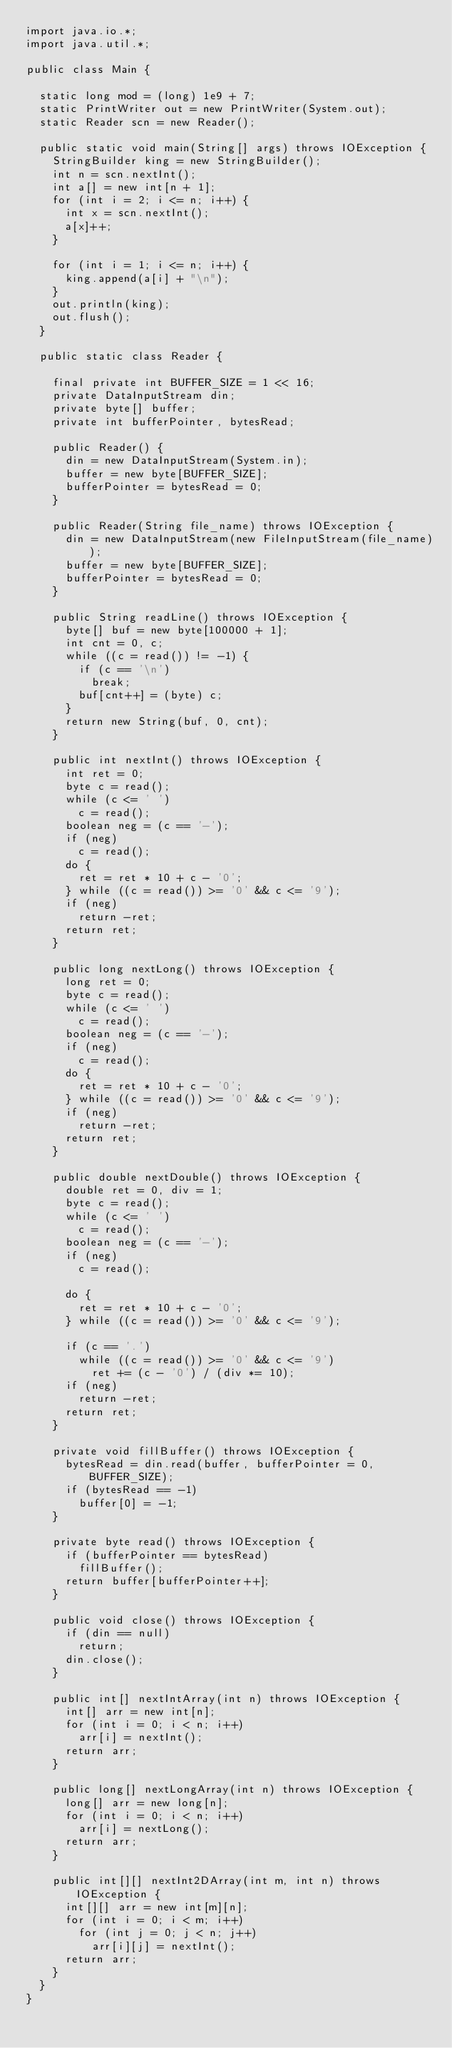<code> <loc_0><loc_0><loc_500><loc_500><_Java_>import java.io.*;
import java.util.*;

public class Main {

	static long mod = (long) 1e9 + 7;
	static PrintWriter out = new PrintWriter(System.out);
	static Reader scn = new Reader();

	public static void main(String[] args) throws IOException {
		StringBuilder king = new StringBuilder();
		int n = scn.nextInt();
		int a[] = new int[n + 1];
		for (int i = 2; i <= n; i++) {
			int x = scn.nextInt();
			a[x]++;
		}

		for (int i = 1; i <= n; i++) {
			king.append(a[i] + "\n");
		}
		out.println(king);
		out.flush();
	}

	public static class Reader {

		final private int BUFFER_SIZE = 1 << 16;
		private DataInputStream din;
		private byte[] buffer;
		private int bufferPointer, bytesRead;

		public Reader() {
			din = new DataInputStream(System.in);
			buffer = new byte[BUFFER_SIZE];
			bufferPointer = bytesRead = 0;
		}

		public Reader(String file_name) throws IOException {
			din = new DataInputStream(new FileInputStream(file_name));
			buffer = new byte[BUFFER_SIZE];
			bufferPointer = bytesRead = 0;
		}

		public String readLine() throws IOException {
			byte[] buf = new byte[100000 + 1];
			int cnt = 0, c;
			while ((c = read()) != -1) {
				if (c == '\n')
					break;
				buf[cnt++] = (byte) c;
			}
			return new String(buf, 0, cnt);
		}

		public int nextInt() throws IOException {
			int ret = 0;
			byte c = read();
			while (c <= ' ')
				c = read();
			boolean neg = (c == '-');
			if (neg)
				c = read();
			do {
				ret = ret * 10 + c - '0';
			} while ((c = read()) >= '0' && c <= '9');
			if (neg)
				return -ret;
			return ret;
		}

		public long nextLong() throws IOException {
			long ret = 0;
			byte c = read();
			while (c <= ' ')
				c = read();
			boolean neg = (c == '-');
			if (neg)
				c = read();
			do {
				ret = ret * 10 + c - '0';
			} while ((c = read()) >= '0' && c <= '9');
			if (neg)
				return -ret;
			return ret;
		}

		public double nextDouble() throws IOException {
			double ret = 0, div = 1;
			byte c = read();
			while (c <= ' ')
				c = read();
			boolean neg = (c == '-');
			if (neg)
				c = read();

			do {
				ret = ret * 10 + c - '0';
			} while ((c = read()) >= '0' && c <= '9');

			if (c == '.')
				while ((c = read()) >= '0' && c <= '9')
					ret += (c - '0') / (div *= 10);
			if (neg)
				return -ret;
			return ret;
		}

		private void fillBuffer() throws IOException {
			bytesRead = din.read(buffer, bufferPointer = 0, BUFFER_SIZE);
			if (bytesRead == -1)
				buffer[0] = -1;
		}

		private byte read() throws IOException {
			if (bufferPointer == bytesRead)
				fillBuffer();
			return buffer[bufferPointer++];
		}

		public void close() throws IOException {
			if (din == null)
				return;
			din.close();
		}

		public int[] nextIntArray(int n) throws IOException {
			int[] arr = new int[n];
			for (int i = 0; i < n; i++)
				arr[i] = nextInt();
			return arr;
		}

		public long[] nextLongArray(int n) throws IOException {
			long[] arr = new long[n];
			for (int i = 0; i < n; i++)
				arr[i] = nextLong();
			return arr;
		}

		public int[][] nextInt2DArray(int m, int n) throws IOException {
			int[][] arr = new int[m][n];
			for (int i = 0; i < m; i++)
				for (int j = 0; j < n; j++)
					arr[i][j] = nextInt();
			return arr;
		}
	}
}</code> 